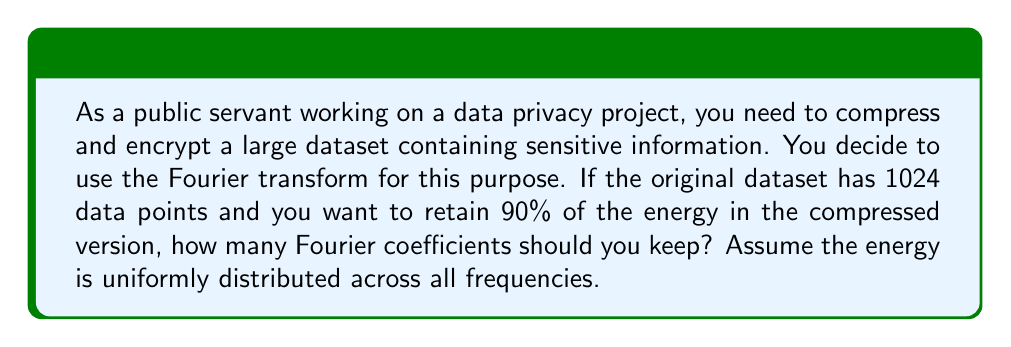Solve this math problem. To solve this problem, we need to understand the relationship between the number of Fourier coefficients and the energy retained in the compressed data. Let's break it down step-by-step:

1. The Discrete Fourier Transform (DFT) of a signal with N points results in N complex Fourier coefficients.

2. In this case, N = 1024 (the number of data points in the original dataset).

3. The energy of a signal is proportional to the sum of the squared magnitudes of its Fourier coefficients. Let's denote the total energy as E:

   $$E = \sum_{k=0}^{N-1} |X[k]|^2$$

   where $X[k]$ are the Fourier coefficients.

4. We want to retain 90% of the energy, which means we need to find the number of coefficients M such that:

   $$\frac{\sum_{k=0}^{M-1} |X[k]|^2}{E} = 0.90$$

5. Since the energy is uniformly distributed across all frequencies, each coefficient contributes an equal amount to the total energy. This means:

   $$\frac{M}{N} = 0.90$$

6. Solving for M:

   $$M = 0.90 \times N = 0.90 \times 1024 = 921.6$$

7. Since we can't have a fractional number of coefficients, we round up to the nearest integer to ensure we retain at least 90% of the energy.

Therefore, we should keep 922 Fourier coefficients to retain at least 90% of the energy in the compressed version of the dataset.
Answer: 922 Fourier coefficients 